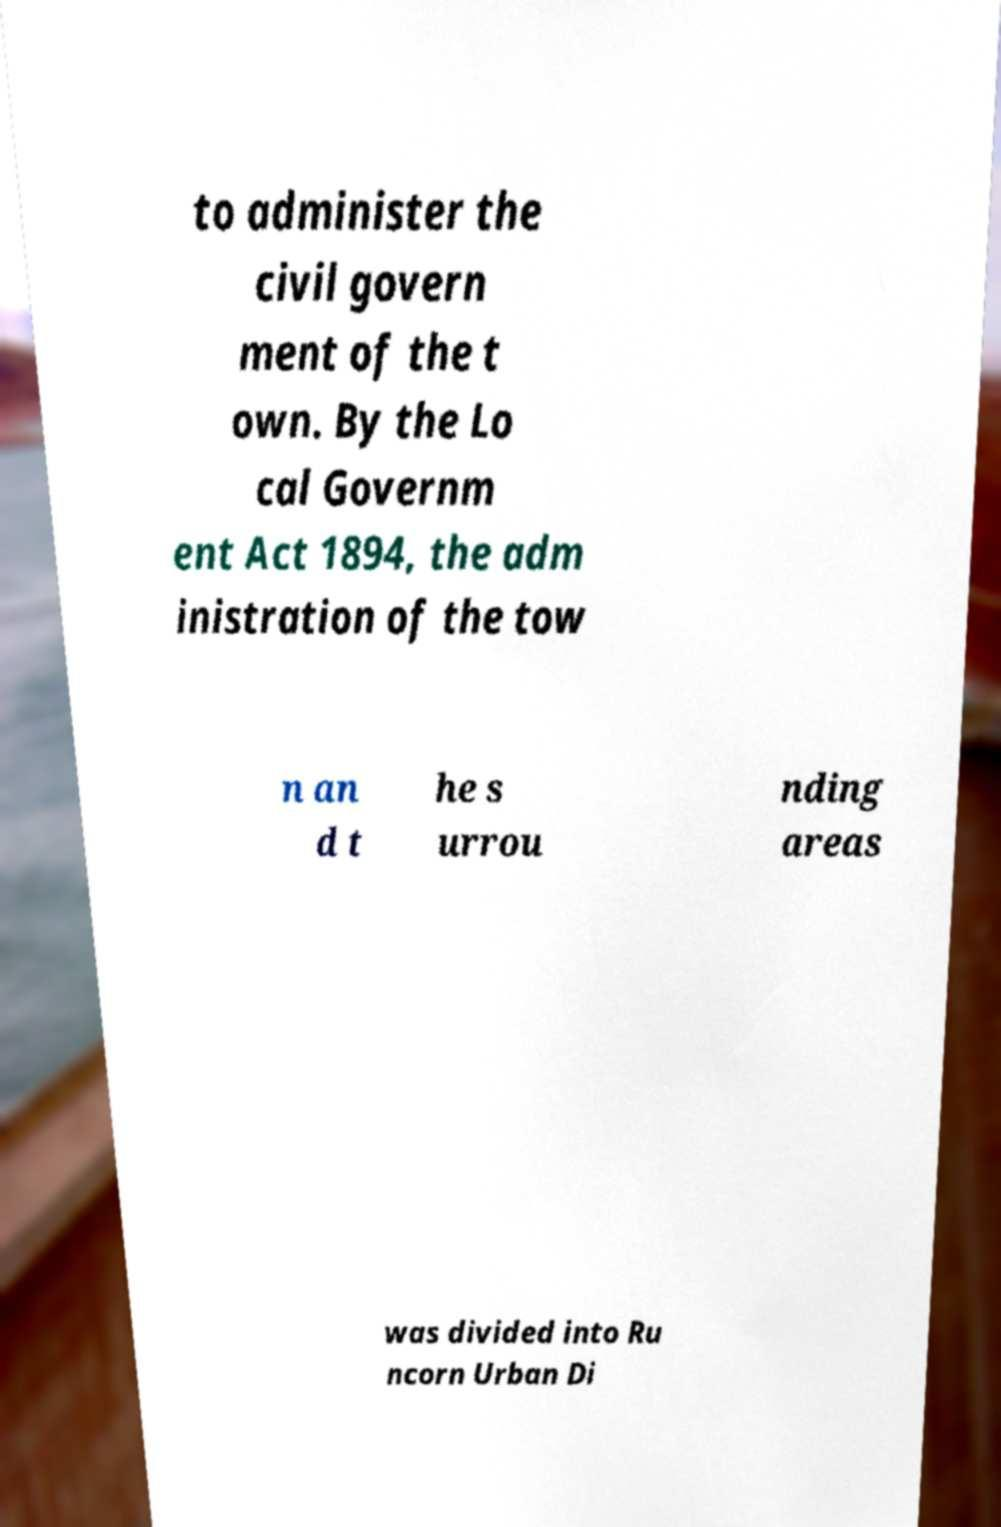Could you assist in decoding the text presented in this image and type it out clearly? to administer the civil govern ment of the t own. By the Lo cal Governm ent Act 1894, the adm inistration of the tow n an d t he s urrou nding areas was divided into Ru ncorn Urban Di 